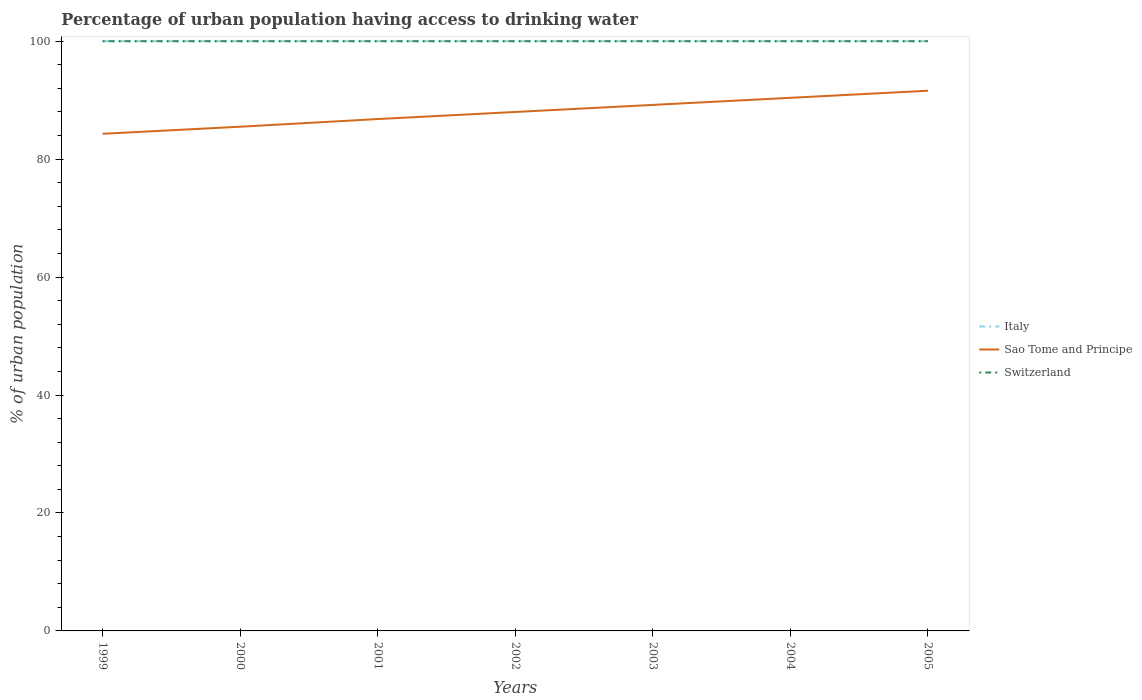Does the line corresponding to Switzerland intersect with the line corresponding to Italy?
Provide a short and direct response. Yes. Is the number of lines equal to the number of legend labels?
Your response must be concise. Yes. Across all years, what is the maximum percentage of urban population having access to drinking water in Sao Tome and Principe?
Offer a terse response. 84.3. What is the total percentage of urban population having access to drinking water in Sao Tome and Principe in the graph?
Offer a terse response. -2.4. What is the difference between the highest and the lowest percentage of urban population having access to drinking water in Italy?
Your answer should be very brief. 0. How many years are there in the graph?
Your answer should be very brief. 7. What is the difference between two consecutive major ticks on the Y-axis?
Your answer should be compact. 20. Are the values on the major ticks of Y-axis written in scientific E-notation?
Make the answer very short. No. Does the graph contain any zero values?
Provide a short and direct response. No. Does the graph contain grids?
Your answer should be compact. No. Where does the legend appear in the graph?
Keep it short and to the point. Center right. How are the legend labels stacked?
Give a very brief answer. Vertical. What is the title of the graph?
Make the answer very short. Percentage of urban population having access to drinking water. Does "Hong Kong" appear as one of the legend labels in the graph?
Offer a very short reply. No. What is the label or title of the X-axis?
Offer a terse response. Years. What is the label or title of the Y-axis?
Your response must be concise. % of urban population. What is the % of urban population of Sao Tome and Principe in 1999?
Your response must be concise. 84.3. What is the % of urban population in Italy in 2000?
Ensure brevity in your answer.  100. What is the % of urban population of Sao Tome and Principe in 2000?
Ensure brevity in your answer.  85.5. What is the % of urban population in Switzerland in 2000?
Make the answer very short. 100. What is the % of urban population in Italy in 2001?
Make the answer very short. 100. What is the % of urban population in Sao Tome and Principe in 2001?
Offer a very short reply. 86.8. What is the % of urban population of Switzerland in 2001?
Provide a succinct answer. 100. What is the % of urban population of Italy in 2002?
Your answer should be compact. 100. What is the % of urban population in Sao Tome and Principe in 2002?
Your answer should be very brief. 88. What is the % of urban population in Sao Tome and Principe in 2003?
Provide a short and direct response. 89.2. What is the % of urban population in Switzerland in 2003?
Give a very brief answer. 100. What is the % of urban population in Italy in 2004?
Provide a short and direct response. 100. What is the % of urban population of Sao Tome and Principe in 2004?
Your answer should be compact. 90.4. What is the % of urban population in Switzerland in 2004?
Your answer should be very brief. 100. What is the % of urban population in Italy in 2005?
Give a very brief answer. 100. What is the % of urban population in Sao Tome and Principe in 2005?
Ensure brevity in your answer.  91.6. What is the % of urban population in Switzerland in 2005?
Keep it short and to the point. 100. Across all years, what is the maximum % of urban population in Sao Tome and Principe?
Your answer should be very brief. 91.6. Across all years, what is the maximum % of urban population in Switzerland?
Provide a short and direct response. 100. Across all years, what is the minimum % of urban population of Italy?
Offer a terse response. 100. Across all years, what is the minimum % of urban population in Sao Tome and Principe?
Ensure brevity in your answer.  84.3. Across all years, what is the minimum % of urban population of Switzerland?
Offer a terse response. 100. What is the total % of urban population of Italy in the graph?
Your answer should be very brief. 700. What is the total % of urban population of Sao Tome and Principe in the graph?
Give a very brief answer. 615.8. What is the total % of urban population of Switzerland in the graph?
Ensure brevity in your answer.  700. What is the difference between the % of urban population of Italy in 1999 and that in 2000?
Keep it short and to the point. 0. What is the difference between the % of urban population in Switzerland in 1999 and that in 2000?
Provide a short and direct response. 0. What is the difference between the % of urban population in Italy in 1999 and that in 2001?
Keep it short and to the point. 0. What is the difference between the % of urban population of Sao Tome and Principe in 1999 and that in 2001?
Provide a short and direct response. -2.5. What is the difference between the % of urban population of Sao Tome and Principe in 1999 and that in 2002?
Your response must be concise. -3.7. What is the difference between the % of urban population of Sao Tome and Principe in 1999 and that in 2003?
Offer a terse response. -4.9. What is the difference between the % of urban population of Switzerland in 1999 and that in 2004?
Provide a succinct answer. 0. What is the difference between the % of urban population in Italy in 1999 and that in 2005?
Provide a short and direct response. 0. What is the difference between the % of urban population in Sao Tome and Principe in 1999 and that in 2005?
Your response must be concise. -7.3. What is the difference between the % of urban population in Switzerland in 1999 and that in 2005?
Your answer should be very brief. 0. What is the difference between the % of urban population in Italy in 2000 and that in 2002?
Provide a short and direct response. 0. What is the difference between the % of urban population in Sao Tome and Principe in 2000 and that in 2002?
Make the answer very short. -2.5. What is the difference between the % of urban population in Switzerland in 2000 and that in 2002?
Your answer should be very brief. 0. What is the difference between the % of urban population of Italy in 2000 and that in 2004?
Keep it short and to the point. 0. What is the difference between the % of urban population of Sao Tome and Principe in 2000 and that in 2004?
Provide a succinct answer. -4.9. What is the difference between the % of urban population of Italy in 2001 and that in 2002?
Make the answer very short. 0. What is the difference between the % of urban population in Switzerland in 2001 and that in 2002?
Offer a terse response. 0. What is the difference between the % of urban population of Sao Tome and Principe in 2001 and that in 2003?
Offer a very short reply. -2.4. What is the difference between the % of urban population in Switzerland in 2001 and that in 2003?
Your response must be concise. 0. What is the difference between the % of urban population in Italy in 2001 and that in 2004?
Your answer should be very brief. 0. What is the difference between the % of urban population in Sao Tome and Principe in 2001 and that in 2004?
Offer a terse response. -3.6. What is the difference between the % of urban population of Switzerland in 2001 and that in 2005?
Your answer should be very brief. 0. What is the difference between the % of urban population of Sao Tome and Principe in 2002 and that in 2003?
Give a very brief answer. -1.2. What is the difference between the % of urban population of Switzerland in 2002 and that in 2004?
Provide a succinct answer. 0. What is the difference between the % of urban population of Sao Tome and Principe in 2002 and that in 2005?
Provide a succinct answer. -3.6. What is the difference between the % of urban population in Switzerland in 2002 and that in 2005?
Your answer should be very brief. 0. What is the difference between the % of urban population of Italy in 2003 and that in 2004?
Provide a succinct answer. 0. What is the difference between the % of urban population of Sao Tome and Principe in 2003 and that in 2004?
Make the answer very short. -1.2. What is the difference between the % of urban population of Switzerland in 2003 and that in 2004?
Ensure brevity in your answer.  0. What is the difference between the % of urban population in Italy in 2003 and that in 2005?
Offer a terse response. 0. What is the difference between the % of urban population of Switzerland in 2003 and that in 2005?
Provide a succinct answer. 0. What is the difference between the % of urban population of Italy in 2004 and that in 2005?
Ensure brevity in your answer.  0. What is the difference between the % of urban population of Sao Tome and Principe in 2004 and that in 2005?
Provide a short and direct response. -1.2. What is the difference between the % of urban population in Switzerland in 2004 and that in 2005?
Your answer should be very brief. 0. What is the difference between the % of urban population of Sao Tome and Principe in 1999 and the % of urban population of Switzerland in 2000?
Make the answer very short. -15.7. What is the difference between the % of urban population of Italy in 1999 and the % of urban population of Sao Tome and Principe in 2001?
Provide a short and direct response. 13.2. What is the difference between the % of urban population in Italy in 1999 and the % of urban population in Switzerland in 2001?
Ensure brevity in your answer.  0. What is the difference between the % of urban population of Sao Tome and Principe in 1999 and the % of urban population of Switzerland in 2001?
Offer a very short reply. -15.7. What is the difference between the % of urban population of Sao Tome and Principe in 1999 and the % of urban population of Switzerland in 2002?
Your response must be concise. -15.7. What is the difference between the % of urban population in Italy in 1999 and the % of urban population in Switzerland in 2003?
Provide a short and direct response. 0. What is the difference between the % of urban population of Sao Tome and Principe in 1999 and the % of urban population of Switzerland in 2003?
Your response must be concise. -15.7. What is the difference between the % of urban population of Italy in 1999 and the % of urban population of Switzerland in 2004?
Your answer should be very brief. 0. What is the difference between the % of urban population of Sao Tome and Principe in 1999 and the % of urban population of Switzerland in 2004?
Make the answer very short. -15.7. What is the difference between the % of urban population of Sao Tome and Principe in 1999 and the % of urban population of Switzerland in 2005?
Your answer should be very brief. -15.7. What is the difference between the % of urban population in Italy in 2000 and the % of urban population in Switzerland in 2001?
Offer a very short reply. 0. What is the difference between the % of urban population of Sao Tome and Principe in 2000 and the % of urban population of Switzerland in 2001?
Make the answer very short. -14.5. What is the difference between the % of urban population of Italy in 2000 and the % of urban population of Sao Tome and Principe in 2002?
Your answer should be compact. 12. What is the difference between the % of urban population in Italy in 2000 and the % of urban population in Switzerland in 2002?
Your answer should be very brief. 0. What is the difference between the % of urban population of Italy in 2000 and the % of urban population of Sao Tome and Principe in 2003?
Give a very brief answer. 10.8. What is the difference between the % of urban population of Italy in 2000 and the % of urban population of Switzerland in 2003?
Offer a very short reply. 0. What is the difference between the % of urban population in Italy in 2000 and the % of urban population in Switzerland in 2004?
Ensure brevity in your answer.  0. What is the difference between the % of urban population of Sao Tome and Principe in 2000 and the % of urban population of Switzerland in 2004?
Offer a terse response. -14.5. What is the difference between the % of urban population in Italy in 2000 and the % of urban population in Sao Tome and Principe in 2005?
Your answer should be compact. 8.4. What is the difference between the % of urban population in Italy in 2001 and the % of urban population in Switzerland in 2002?
Your response must be concise. 0. What is the difference between the % of urban population in Sao Tome and Principe in 2001 and the % of urban population in Switzerland in 2003?
Offer a terse response. -13.2. What is the difference between the % of urban population of Italy in 2001 and the % of urban population of Switzerland in 2004?
Give a very brief answer. 0. What is the difference between the % of urban population in Italy in 2001 and the % of urban population in Switzerland in 2005?
Ensure brevity in your answer.  0. What is the difference between the % of urban population of Sao Tome and Principe in 2001 and the % of urban population of Switzerland in 2005?
Provide a succinct answer. -13.2. What is the difference between the % of urban population in Italy in 2002 and the % of urban population in Switzerland in 2003?
Keep it short and to the point. 0. What is the difference between the % of urban population in Sao Tome and Principe in 2002 and the % of urban population in Switzerland in 2003?
Your answer should be very brief. -12. What is the difference between the % of urban population of Italy in 2002 and the % of urban population of Switzerland in 2005?
Ensure brevity in your answer.  0. What is the difference between the % of urban population of Sao Tome and Principe in 2002 and the % of urban population of Switzerland in 2005?
Offer a very short reply. -12. What is the difference between the % of urban population of Italy in 2003 and the % of urban population of Switzerland in 2004?
Keep it short and to the point. 0. What is the difference between the % of urban population of Sao Tome and Principe in 2003 and the % of urban population of Switzerland in 2004?
Give a very brief answer. -10.8. What is the difference between the % of urban population of Italy in 2003 and the % of urban population of Sao Tome and Principe in 2005?
Make the answer very short. 8.4. What is the difference between the % of urban population in Sao Tome and Principe in 2003 and the % of urban population in Switzerland in 2005?
Ensure brevity in your answer.  -10.8. What is the difference between the % of urban population in Italy in 2004 and the % of urban population in Sao Tome and Principe in 2005?
Keep it short and to the point. 8.4. What is the difference between the % of urban population in Italy in 2004 and the % of urban population in Switzerland in 2005?
Your response must be concise. 0. What is the average % of urban population in Sao Tome and Principe per year?
Provide a succinct answer. 87.97. In the year 1999, what is the difference between the % of urban population in Italy and % of urban population in Switzerland?
Make the answer very short. 0. In the year 1999, what is the difference between the % of urban population in Sao Tome and Principe and % of urban population in Switzerland?
Ensure brevity in your answer.  -15.7. In the year 2000, what is the difference between the % of urban population in Italy and % of urban population in Switzerland?
Provide a short and direct response. 0. In the year 2000, what is the difference between the % of urban population in Sao Tome and Principe and % of urban population in Switzerland?
Offer a very short reply. -14.5. In the year 2001, what is the difference between the % of urban population in Italy and % of urban population in Sao Tome and Principe?
Give a very brief answer. 13.2. In the year 2001, what is the difference between the % of urban population in Italy and % of urban population in Switzerland?
Ensure brevity in your answer.  0. In the year 2002, what is the difference between the % of urban population in Italy and % of urban population in Sao Tome and Principe?
Your response must be concise. 12. In the year 2002, what is the difference between the % of urban population of Sao Tome and Principe and % of urban population of Switzerland?
Make the answer very short. -12. In the year 2003, what is the difference between the % of urban population in Italy and % of urban population in Sao Tome and Principe?
Provide a succinct answer. 10.8. In the year 2004, what is the difference between the % of urban population of Italy and % of urban population of Switzerland?
Keep it short and to the point. 0. What is the ratio of the % of urban population of Italy in 1999 to that in 2000?
Give a very brief answer. 1. What is the ratio of the % of urban population in Switzerland in 1999 to that in 2000?
Your answer should be very brief. 1. What is the ratio of the % of urban population of Italy in 1999 to that in 2001?
Your response must be concise. 1. What is the ratio of the % of urban population in Sao Tome and Principe in 1999 to that in 2001?
Provide a succinct answer. 0.97. What is the ratio of the % of urban population of Italy in 1999 to that in 2002?
Ensure brevity in your answer.  1. What is the ratio of the % of urban population in Sao Tome and Principe in 1999 to that in 2002?
Make the answer very short. 0.96. What is the ratio of the % of urban population in Sao Tome and Principe in 1999 to that in 2003?
Give a very brief answer. 0.95. What is the ratio of the % of urban population of Switzerland in 1999 to that in 2003?
Provide a succinct answer. 1. What is the ratio of the % of urban population of Italy in 1999 to that in 2004?
Ensure brevity in your answer.  1. What is the ratio of the % of urban population in Sao Tome and Principe in 1999 to that in 2004?
Ensure brevity in your answer.  0.93. What is the ratio of the % of urban population of Italy in 1999 to that in 2005?
Your answer should be compact. 1. What is the ratio of the % of urban population in Sao Tome and Principe in 1999 to that in 2005?
Offer a very short reply. 0.92. What is the ratio of the % of urban population in Italy in 2000 to that in 2002?
Your response must be concise. 1. What is the ratio of the % of urban population of Sao Tome and Principe in 2000 to that in 2002?
Provide a succinct answer. 0.97. What is the ratio of the % of urban population in Switzerland in 2000 to that in 2002?
Your answer should be very brief. 1. What is the ratio of the % of urban population of Italy in 2000 to that in 2003?
Provide a short and direct response. 1. What is the ratio of the % of urban population in Sao Tome and Principe in 2000 to that in 2003?
Keep it short and to the point. 0.96. What is the ratio of the % of urban population of Switzerland in 2000 to that in 2003?
Your answer should be compact. 1. What is the ratio of the % of urban population in Sao Tome and Principe in 2000 to that in 2004?
Keep it short and to the point. 0.95. What is the ratio of the % of urban population in Switzerland in 2000 to that in 2004?
Your response must be concise. 1. What is the ratio of the % of urban population of Italy in 2000 to that in 2005?
Offer a terse response. 1. What is the ratio of the % of urban population of Sao Tome and Principe in 2000 to that in 2005?
Make the answer very short. 0.93. What is the ratio of the % of urban population in Italy in 2001 to that in 2002?
Give a very brief answer. 1. What is the ratio of the % of urban population in Sao Tome and Principe in 2001 to that in 2002?
Provide a short and direct response. 0.99. What is the ratio of the % of urban population in Switzerland in 2001 to that in 2002?
Give a very brief answer. 1. What is the ratio of the % of urban population in Italy in 2001 to that in 2003?
Keep it short and to the point. 1. What is the ratio of the % of urban population in Sao Tome and Principe in 2001 to that in 2003?
Your answer should be compact. 0.97. What is the ratio of the % of urban population of Sao Tome and Principe in 2001 to that in 2004?
Ensure brevity in your answer.  0.96. What is the ratio of the % of urban population in Sao Tome and Principe in 2001 to that in 2005?
Offer a terse response. 0.95. What is the ratio of the % of urban population in Italy in 2002 to that in 2003?
Your answer should be very brief. 1. What is the ratio of the % of urban population of Sao Tome and Principe in 2002 to that in 2003?
Keep it short and to the point. 0.99. What is the ratio of the % of urban population in Switzerland in 2002 to that in 2003?
Your answer should be compact. 1. What is the ratio of the % of urban population in Italy in 2002 to that in 2004?
Offer a very short reply. 1. What is the ratio of the % of urban population in Sao Tome and Principe in 2002 to that in 2004?
Give a very brief answer. 0.97. What is the ratio of the % of urban population of Switzerland in 2002 to that in 2004?
Provide a short and direct response. 1. What is the ratio of the % of urban population of Italy in 2002 to that in 2005?
Provide a succinct answer. 1. What is the ratio of the % of urban population of Sao Tome and Principe in 2002 to that in 2005?
Provide a succinct answer. 0.96. What is the ratio of the % of urban population in Switzerland in 2002 to that in 2005?
Make the answer very short. 1. What is the ratio of the % of urban population in Italy in 2003 to that in 2004?
Give a very brief answer. 1. What is the ratio of the % of urban population in Sao Tome and Principe in 2003 to that in 2004?
Provide a short and direct response. 0.99. What is the ratio of the % of urban population of Switzerland in 2003 to that in 2004?
Your response must be concise. 1. What is the ratio of the % of urban population in Sao Tome and Principe in 2003 to that in 2005?
Provide a short and direct response. 0.97. What is the ratio of the % of urban population of Italy in 2004 to that in 2005?
Your response must be concise. 1. What is the ratio of the % of urban population of Sao Tome and Principe in 2004 to that in 2005?
Provide a succinct answer. 0.99. What is the ratio of the % of urban population in Switzerland in 2004 to that in 2005?
Your answer should be compact. 1. What is the difference between the highest and the second highest % of urban population of Italy?
Your answer should be very brief. 0. What is the difference between the highest and the second highest % of urban population of Sao Tome and Principe?
Keep it short and to the point. 1.2. 